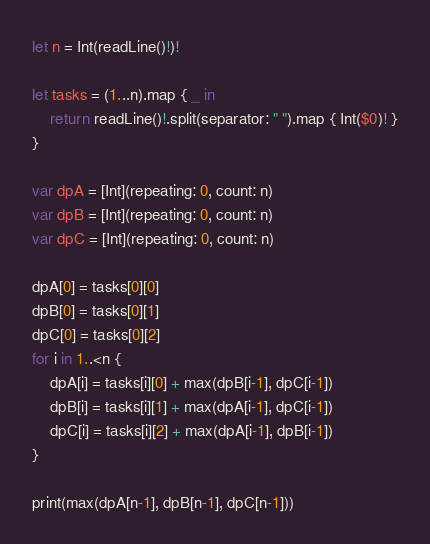<code> <loc_0><loc_0><loc_500><loc_500><_Swift_>let n = Int(readLine()!)!

let tasks = (1...n).map { _ in
    return readLine()!.split(separator: " ").map { Int($0)! }
}

var dpA = [Int](repeating: 0, count: n)
var dpB = [Int](repeating: 0, count: n)
var dpC = [Int](repeating: 0, count: n)

dpA[0] = tasks[0][0]
dpB[0] = tasks[0][1]
dpC[0] = tasks[0][2]
for i in 1..<n {
    dpA[i] = tasks[i][0] + max(dpB[i-1], dpC[i-1])
    dpB[i] = tasks[i][1] + max(dpA[i-1], dpC[i-1])
    dpC[i] = tasks[i][2] + max(dpA[i-1], dpB[i-1])
}

print(max(dpA[n-1], dpB[n-1], dpC[n-1]))</code> 